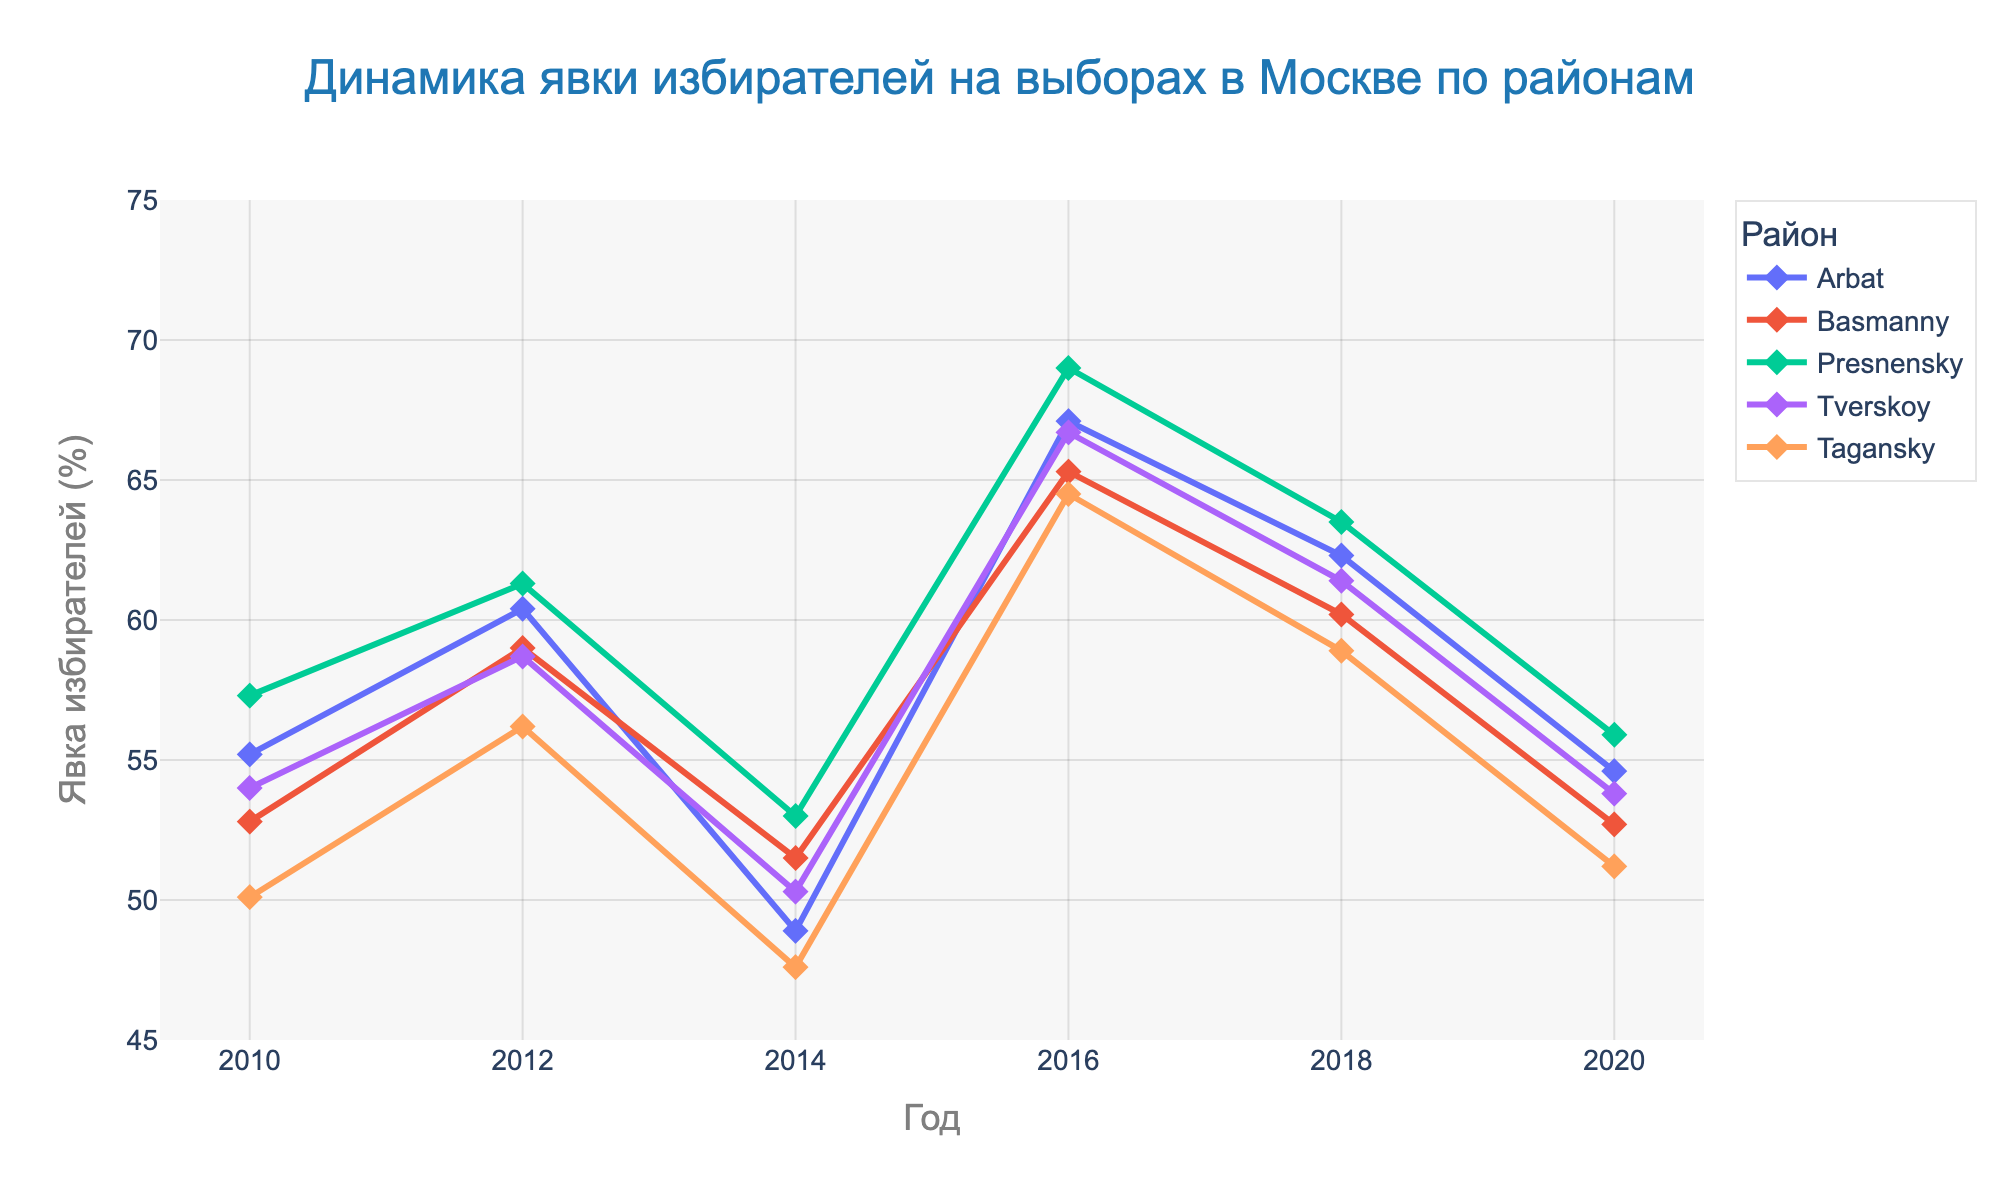What is the title of the plot? The title is located at the top of the plot, written in a large and bold font.
Answer: Динамика явки избирателей на выборах в Москве по районам What year showed the highest voter turnout in the Arbat district? Locate the line corresponding to the Arbat district, then find the highest data point along this line.
Answer: 2016 Which district had the lowest voter turnout in 2014? Identify the lines representing 2014 data points, then find the lowest data point among them.
Answer: Tagansky What is the general trend of voter turnout in the Presnensky district over the years? Follow the line corresponding to the Presnensky district to observe how the values change over the years.
Answer: Fluctuating How many districts are represented in the plot? Count the unique lines with different district names in the legend.
Answer: 5 Which year had the most consistent voter turnout across all districts? Compare the spread of data points for each year to see which year's data points are closest together.
Answer: 2018 Between which years did the Basmanny district see the largest increase in voter turnout? Locate the line for the Basmanny district, then identify the largest vertical gap between two consecutive data points.
Answer: 2014 to 2016 What is the range of voter turnout percentages shown on the y-axis? Look at the minimum and maximum values marked on the y-axis.
Answer: 45% to 75% How did the voter turnout in the Tverskoy district change from 2018 to 2020? Observe the slope of the line segment for Tverskoy district between 2018 and 2020.
Answer: Decreased What was the voter turnout in the Tagansky district in 2012? Find the data point for Tagansky district corresponding to the year 2012.
Answer: 56.2% 